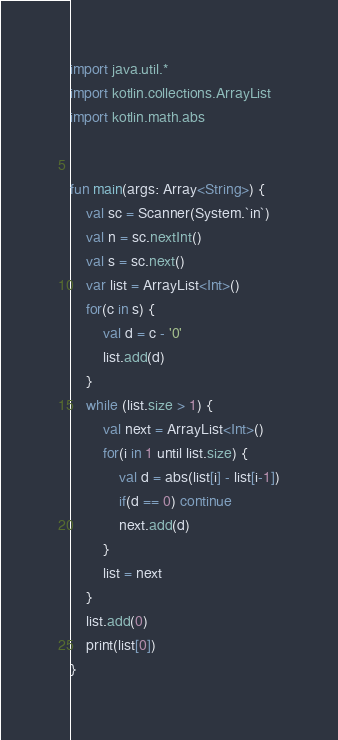Convert code to text. <code><loc_0><loc_0><loc_500><loc_500><_Kotlin_>
import java.util.*
import kotlin.collections.ArrayList
import kotlin.math.abs


fun main(args: Array<String>) {
    val sc = Scanner(System.`in`)
    val n = sc.nextInt()
    val s = sc.next()
    var list = ArrayList<Int>()
    for(c in s) {
        val d = c - '0'
        list.add(d)
    }
    while (list.size > 1) {
        val next = ArrayList<Int>()
        for(i in 1 until list.size) {
            val d = abs(list[i] - list[i-1])
            if(d == 0) continue
            next.add(d)
        }
        list = next
    }
    list.add(0)
    print(list[0])
}

</code> 